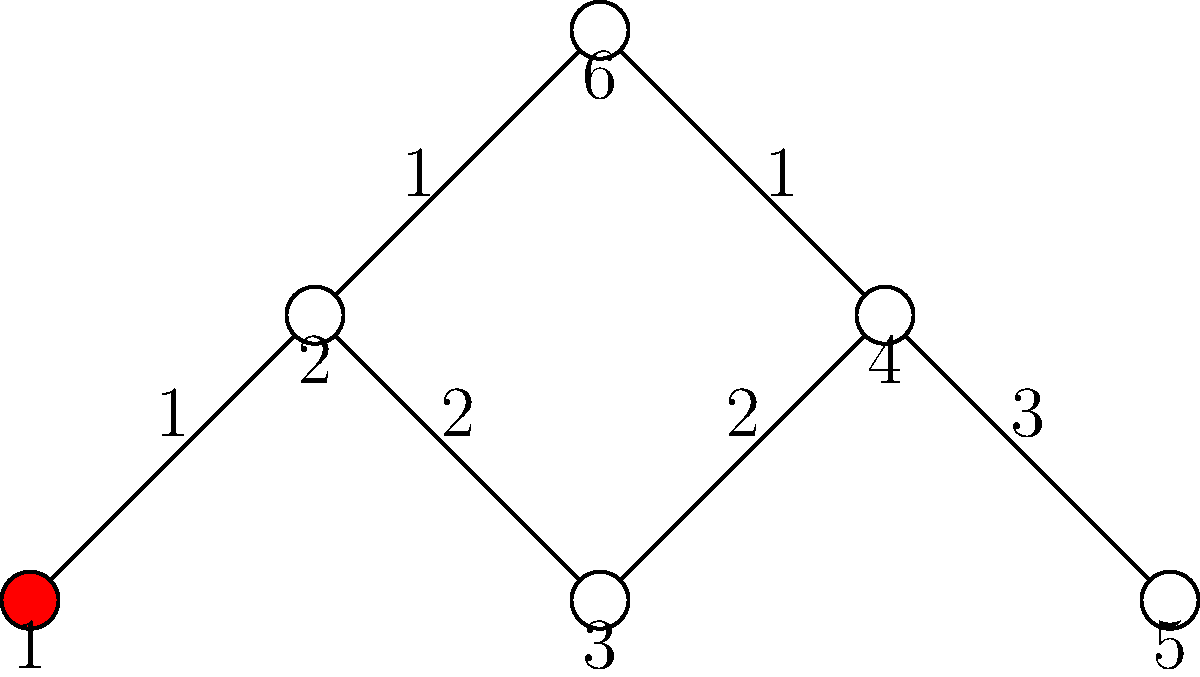Given the network graph representing interconnected systems, where node 1 is the initial point of a cyber attack, and the numbers on the edges represent the time (in hours) for the attack to propagate between connected systems, what is the minimum time required for the attack to reach all systems in the network? To find the minimum time for the attack to reach all systems, we need to determine the shortest path from node 1 to all other nodes:

1. Node 1 is the starting point (time = 0 hours)
2. Node 2: Directly connected to node 1, time = 1 hour
3. Node 3: Can be reached through node 2, time = 1 + 2 = 3 hours
4. Node 4: Two possible paths:
   a. Through nodes 2 and 3: 1 + 2 + 2 = 5 hours
   b. Through nodes 2, 6, and 4: 1 + 1 + 1 = 3 hours
   Minimum time to reach node 4 = 3 hours
5. Node 5: Can only be reached through nodes 2, 3, and 4: 1 + 2 + 2 + 3 = 8 hours
6. Node 6: Can be reached through node 2: 1 + 1 = 2 hours

The minimum time required for the attack to reach all systems is the maximum of these times: max(0, 1, 3, 3, 8, 2) = 8 hours.
Answer: 8 hours 